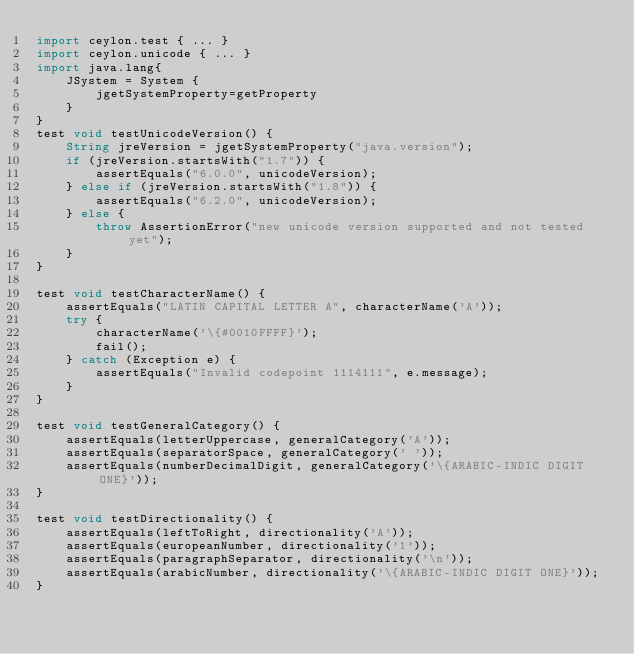Convert code to text. <code><loc_0><loc_0><loc_500><loc_500><_Ceylon_>import ceylon.test { ... }
import ceylon.unicode { ... }
import java.lang{
    JSystem = System { 
        jgetSystemProperty=getProperty 
    }
}
test void testUnicodeVersion() {
    String jreVersion = jgetSystemProperty("java.version");
    if (jreVersion.startsWith("1.7")) {
        assertEquals("6.0.0", unicodeVersion);
    } else if (jreVersion.startsWith("1.8")) {
        assertEquals("6.2.0", unicodeVersion);
    } else {
        throw AssertionError("new unicode version supported and not tested yet");
    }
}

test void testCharacterName() {
    assertEquals("LATIN CAPITAL LETTER A", characterName('A'));
    try {
        characterName('\{#0010FFFF}');
        fail();
    } catch (Exception e) {
        assertEquals("Invalid codepoint 1114111", e.message);
    }
}

test void testGeneralCategory() {
    assertEquals(letterUppercase, generalCategory('A'));
    assertEquals(separatorSpace, generalCategory(' '));
    assertEquals(numberDecimalDigit, generalCategory('\{ARABIC-INDIC DIGIT ONE}'));
}

test void testDirectionality() {
    assertEquals(leftToRight, directionality('A'));
    assertEquals(europeanNumber, directionality('1'));
    assertEquals(paragraphSeparator, directionality('\n'));
    assertEquals(arabicNumber, directionality('\{ARABIC-INDIC DIGIT ONE}'));
}</code> 